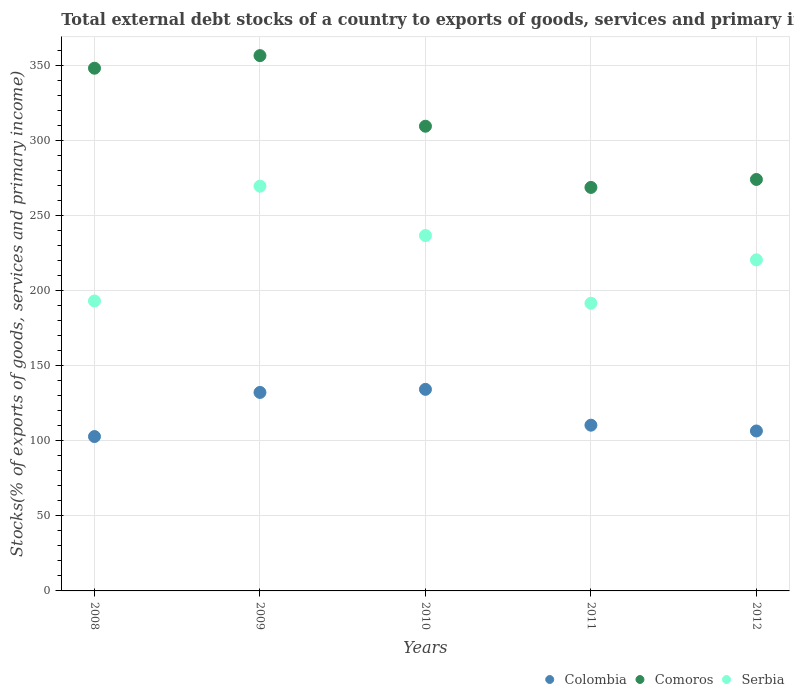What is the total debt stocks in Comoros in 2011?
Your response must be concise. 268.71. Across all years, what is the maximum total debt stocks in Comoros?
Give a very brief answer. 356.48. Across all years, what is the minimum total debt stocks in Colombia?
Your answer should be compact. 102.8. What is the total total debt stocks in Colombia in the graph?
Make the answer very short. 586.12. What is the difference between the total debt stocks in Colombia in 2011 and that in 2012?
Offer a very short reply. 3.86. What is the difference between the total debt stocks in Comoros in 2010 and the total debt stocks in Serbia in 2012?
Your response must be concise. 88.97. What is the average total debt stocks in Serbia per year?
Your answer should be very brief. 222.27. In the year 2009, what is the difference between the total debt stocks in Colombia and total debt stocks in Serbia?
Offer a very short reply. -137.37. What is the ratio of the total debt stocks in Colombia in 2008 to that in 2011?
Ensure brevity in your answer.  0.93. Is the difference between the total debt stocks in Colombia in 2011 and 2012 greater than the difference between the total debt stocks in Serbia in 2011 and 2012?
Ensure brevity in your answer.  Yes. What is the difference between the highest and the second highest total debt stocks in Serbia?
Keep it short and to the point. 32.89. What is the difference between the highest and the lowest total debt stocks in Comoros?
Your answer should be very brief. 87.77. In how many years, is the total debt stocks in Comoros greater than the average total debt stocks in Comoros taken over all years?
Offer a terse response. 2. Is the total debt stocks in Serbia strictly greater than the total debt stocks in Comoros over the years?
Offer a terse response. No. How many dotlines are there?
Provide a short and direct response. 3. How many years are there in the graph?
Your answer should be very brief. 5. Are the values on the major ticks of Y-axis written in scientific E-notation?
Provide a succinct answer. No. Does the graph contain any zero values?
Provide a succinct answer. No. Where does the legend appear in the graph?
Offer a terse response. Bottom right. How many legend labels are there?
Give a very brief answer. 3. What is the title of the graph?
Provide a short and direct response. Total external debt stocks of a country to exports of goods, services and primary income. Does "Middle East & North Africa (all income levels)" appear as one of the legend labels in the graph?
Offer a terse response. No. What is the label or title of the X-axis?
Make the answer very short. Years. What is the label or title of the Y-axis?
Give a very brief answer. Stocks(% of exports of goods, services and primary income). What is the Stocks(% of exports of goods, services and primary income) of Colombia in 2008?
Your response must be concise. 102.8. What is the Stocks(% of exports of goods, services and primary income) of Comoros in 2008?
Keep it short and to the point. 348.1. What is the Stocks(% of exports of goods, services and primary income) in Serbia in 2008?
Provide a short and direct response. 193.09. What is the Stocks(% of exports of goods, services and primary income) in Colombia in 2009?
Provide a succinct answer. 132.18. What is the Stocks(% of exports of goods, services and primary income) of Comoros in 2009?
Keep it short and to the point. 356.48. What is the Stocks(% of exports of goods, services and primary income) of Serbia in 2009?
Offer a very short reply. 269.55. What is the Stocks(% of exports of goods, services and primary income) in Colombia in 2010?
Your answer should be compact. 134.24. What is the Stocks(% of exports of goods, services and primary income) of Comoros in 2010?
Offer a very short reply. 309.46. What is the Stocks(% of exports of goods, services and primary income) in Serbia in 2010?
Keep it short and to the point. 236.67. What is the Stocks(% of exports of goods, services and primary income) of Colombia in 2011?
Provide a succinct answer. 110.38. What is the Stocks(% of exports of goods, services and primary income) of Comoros in 2011?
Offer a terse response. 268.71. What is the Stocks(% of exports of goods, services and primary income) in Serbia in 2011?
Make the answer very short. 191.56. What is the Stocks(% of exports of goods, services and primary income) of Colombia in 2012?
Make the answer very short. 106.52. What is the Stocks(% of exports of goods, services and primary income) of Comoros in 2012?
Provide a short and direct response. 274.02. What is the Stocks(% of exports of goods, services and primary income) in Serbia in 2012?
Provide a succinct answer. 220.5. Across all years, what is the maximum Stocks(% of exports of goods, services and primary income) of Colombia?
Provide a succinct answer. 134.24. Across all years, what is the maximum Stocks(% of exports of goods, services and primary income) of Comoros?
Provide a succinct answer. 356.48. Across all years, what is the maximum Stocks(% of exports of goods, services and primary income) of Serbia?
Ensure brevity in your answer.  269.55. Across all years, what is the minimum Stocks(% of exports of goods, services and primary income) in Colombia?
Keep it short and to the point. 102.8. Across all years, what is the minimum Stocks(% of exports of goods, services and primary income) in Comoros?
Provide a short and direct response. 268.71. Across all years, what is the minimum Stocks(% of exports of goods, services and primary income) of Serbia?
Your response must be concise. 191.56. What is the total Stocks(% of exports of goods, services and primary income) in Colombia in the graph?
Provide a succinct answer. 586.12. What is the total Stocks(% of exports of goods, services and primary income) of Comoros in the graph?
Provide a succinct answer. 1556.78. What is the total Stocks(% of exports of goods, services and primary income) in Serbia in the graph?
Your response must be concise. 1111.37. What is the difference between the Stocks(% of exports of goods, services and primary income) of Colombia in 2008 and that in 2009?
Provide a short and direct response. -29.38. What is the difference between the Stocks(% of exports of goods, services and primary income) of Comoros in 2008 and that in 2009?
Your answer should be compact. -8.38. What is the difference between the Stocks(% of exports of goods, services and primary income) of Serbia in 2008 and that in 2009?
Ensure brevity in your answer.  -76.47. What is the difference between the Stocks(% of exports of goods, services and primary income) in Colombia in 2008 and that in 2010?
Your response must be concise. -31.43. What is the difference between the Stocks(% of exports of goods, services and primary income) of Comoros in 2008 and that in 2010?
Offer a terse response. 38.64. What is the difference between the Stocks(% of exports of goods, services and primary income) of Serbia in 2008 and that in 2010?
Provide a succinct answer. -43.58. What is the difference between the Stocks(% of exports of goods, services and primary income) in Colombia in 2008 and that in 2011?
Your answer should be compact. -7.58. What is the difference between the Stocks(% of exports of goods, services and primary income) of Comoros in 2008 and that in 2011?
Provide a succinct answer. 79.39. What is the difference between the Stocks(% of exports of goods, services and primary income) in Serbia in 2008 and that in 2011?
Give a very brief answer. 1.53. What is the difference between the Stocks(% of exports of goods, services and primary income) of Colombia in 2008 and that in 2012?
Your answer should be very brief. -3.71. What is the difference between the Stocks(% of exports of goods, services and primary income) in Comoros in 2008 and that in 2012?
Offer a terse response. 74.08. What is the difference between the Stocks(% of exports of goods, services and primary income) of Serbia in 2008 and that in 2012?
Your response must be concise. -27.41. What is the difference between the Stocks(% of exports of goods, services and primary income) in Colombia in 2009 and that in 2010?
Your answer should be very brief. -2.05. What is the difference between the Stocks(% of exports of goods, services and primary income) of Comoros in 2009 and that in 2010?
Ensure brevity in your answer.  47.02. What is the difference between the Stocks(% of exports of goods, services and primary income) in Serbia in 2009 and that in 2010?
Ensure brevity in your answer.  32.89. What is the difference between the Stocks(% of exports of goods, services and primary income) of Colombia in 2009 and that in 2011?
Offer a terse response. 21.81. What is the difference between the Stocks(% of exports of goods, services and primary income) in Comoros in 2009 and that in 2011?
Your answer should be compact. 87.77. What is the difference between the Stocks(% of exports of goods, services and primary income) of Serbia in 2009 and that in 2011?
Offer a very short reply. 77.99. What is the difference between the Stocks(% of exports of goods, services and primary income) of Colombia in 2009 and that in 2012?
Provide a succinct answer. 25.67. What is the difference between the Stocks(% of exports of goods, services and primary income) of Comoros in 2009 and that in 2012?
Offer a terse response. 82.47. What is the difference between the Stocks(% of exports of goods, services and primary income) of Serbia in 2009 and that in 2012?
Provide a short and direct response. 49.06. What is the difference between the Stocks(% of exports of goods, services and primary income) in Colombia in 2010 and that in 2011?
Provide a succinct answer. 23.86. What is the difference between the Stocks(% of exports of goods, services and primary income) in Comoros in 2010 and that in 2011?
Ensure brevity in your answer.  40.75. What is the difference between the Stocks(% of exports of goods, services and primary income) of Serbia in 2010 and that in 2011?
Your answer should be very brief. 45.11. What is the difference between the Stocks(% of exports of goods, services and primary income) of Colombia in 2010 and that in 2012?
Your answer should be very brief. 27.72. What is the difference between the Stocks(% of exports of goods, services and primary income) of Comoros in 2010 and that in 2012?
Give a very brief answer. 35.44. What is the difference between the Stocks(% of exports of goods, services and primary income) of Serbia in 2010 and that in 2012?
Keep it short and to the point. 16.17. What is the difference between the Stocks(% of exports of goods, services and primary income) of Colombia in 2011 and that in 2012?
Your answer should be compact. 3.86. What is the difference between the Stocks(% of exports of goods, services and primary income) in Comoros in 2011 and that in 2012?
Ensure brevity in your answer.  -5.31. What is the difference between the Stocks(% of exports of goods, services and primary income) in Serbia in 2011 and that in 2012?
Keep it short and to the point. -28.94. What is the difference between the Stocks(% of exports of goods, services and primary income) in Colombia in 2008 and the Stocks(% of exports of goods, services and primary income) in Comoros in 2009?
Keep it short and to the point. -253.68. What is the difference between the Stocks(% of exports of goods, services and primary income) of Colombia in 2008 and the Stocks(% of exports of goods, services and primary income) of Serbia in 2009?
Keep it short and to the point. -166.75. What is the difference between the Stocks(% of exports of goods, services and primary income) in Comoros in 2008 and the Stocks(% of exports of goods, services and primary income) in Serbia in 2009?
Your response must be concise. 78.55. What is the difference between the Stocks(% of exports of goods, services and primary income) in Colombia in 2008 and the Stocks(% of exports of goods, services and primary income) in Comoros in 2010?
Keep it short and to the point. -206.66. What is the difference between the Stocks(% of exports of goods, services and primary income) in Colombia in 2008 and the Stocks(% of exports of goods, services and primary income) in Serbia in 2010?
Provide a short and direct response. -133.87. What is the difference between the Stocks(% of exports of goods, services and primary income) in Comoros in 2008 and the Stocks(% of exports of goods, services and primary income) in Serbia in 2010?
Keep it short and to the point. 111.43. What is the difference between the Stocks(% of exports of goods, services and primary income) of Colombia in 2008 and the Stocks(% of exports of goods, services and primary income) of Comoros in 2011?
Your answer should be compact. -165.91. What is the difference between the Stocks(% of exports of goods, services and primary income) in Colombia in 2008 and the Stocks(% of exports of goods, services and primary income) in Serbia in 2011?
Provide a short and direct response. -88.76. What is the difference between the Stocks(% of exports of goods, services and primary income) of Comoros in 2008 and the Stocks(% of exports of goods, services and primary income) of Serbia in 2011?
Give a very brief answer. 156.54. What is the difference between the Stocks(% of exports of goods, services and primary income) of Colombia in 2008 and the Stocks(% of exports of goods, services and primary income) of Comoros in 2012?
Keep it short and to the point. -171.21. What is the difference between the Stocks(% of exports of goods, services and primary income) in Colombia in 2008 and the Stocks(% of exports of goods, services and primary income) in Serbia in 2012?
Your response must be concise. -117.69. What is the difference between the Stocks(% of exports of goods, services and primary income) of Comoros in 2008 and the Stocks(% of exports of goods, services and primary income) of Serbia in 2012?
Keep it short and to the point. 127.6. What is the difference between the Stocks(% of exports of goods, services and primary income) of Colombia in 2009 and the Stocks(% of exports of goods, services and primary income) of Comoros in 2010?
Your answer should be very brief. -177.28. What is the difference between the Stocks(% of exports of goods, services and primary income) of Colombia in 2009 and the Stocks(% of exports of goods, services and primary income) of Serbia in 2010?
Offer a very short reply. -104.48. What is the difference between the Stocks(% of exports of goods, services and primary income) in Comoros in 2009 and the Stocks(% of exports of goods, services and primary income) in Serbia in 2010?
Your response must be concise. 119.82. What is the difference between the Stocks(% of exports of goods, services and primary income) in Colombia in 2009 and the Stocks(% of exports of goods, services and primary income) in Comoros in 2011?
Your response must be concise. -136.53. What is the difference between the Stocks(% of exports of goods, services and primary income) of Colombia in 2009 and the Stocks(% of exports of goods, services and primary income) of Serbia in 2011?
Your response must be concise. -59.38. What is the difference between the Stocks(% of exports of goods, services and primary income) of Comoros in 2009 and the Stocks(% of exports of goods, services and primary income) of Serbia in 2011?
Make the answer very short. 164.92. What is the difference between the Stocks(% of exports of goods, services and primary income) of Colombia in 2009 and the Stocks(% of exports of goods, services and primary income) of Comoros in 2012?
Offer a terse response. -141.83. What is the difference between the Stocks(% of exports of goods, services and primary income) in Colombia in 2009 and the Stocks(% of exports of goods, services and primary income) in Serbia in 2012?
Make the answer very short. -88.31. What is the difference between the Stocks(% of exports of goods, services and primary income) of Comoros in 2009 and the Stocks(% of exports of goods, services and primary income) of Serbia in 2012?
Ensure brevity in your answer.  135.99. What is the difference between the Stocks(% of exports of goods, services and primary income) in Colombia in 2010 and the Stocks(% of exports of goods, services and primary income) in Comoros in 2011?
Your response must be concise. -134.47. What is the difference between the Stocks(% of exports of goods, services and primary income) of Colombia in 2010 and the Stocks(% of exports of goods, services and primary income) of Serbia in 2011?
Ensure brevity in your answer.  -57.32. What is the difference between the Stocks(% of exports of goods, services and primary income) in Comoros in 2010 and the Stocks(% of exports of goods, services and primary income) in Serbia in 2011?
Your response must be concise. 117.9. What is the difference between the Stocks(% of exports of goods, services and primary income) in Colombia in 2010 and the Stocks(% of exports of goods, services and primary income) in Comoros in 2012?
Keep it short and to the point. -139.78. What is the difference between the Stocks(% of exports of goods, services and primary income) in Colombia in 2010 and the Stocks(% of exports of goods, services and primary income) in Serbia in 2012?
Offer a very short reply. -86.26. What is the difference between the Stocks(% of exports of goods, services and primary income) of Comoros in 2010 and the Stocks(% of exports of goods, services and primary income) of Serbia in 2012?
Offer a terse response. 88.97. What is the difference between the Stocks(% of exports of goods, services and primary income) in Colombia in 2011 and the Stocks(% of exports of goods, services and primary income) in Comoros in 2012?
Give a very brief answer. -163.64. What is the difference between the Stocks(% of exports of goods, services and primary income) in Colombia in 2011 and the Stocks(% of exports of goods, services and primary income) in Serbia in 2012?
Provide a succinct answer. -110.12. What is the difference between the Stocks(% of exports of goods, services and primary income) of Comoros in 2011 and the Stocks(% of exports of goods, services and primary income) of Serbia in 2012?
Your response must be concise. 48.22. What is the average Stocks(% of exports of goods, services and primary income) in Colombia per year?
Ensure brevity in your answer.  117.22. What is the average Stocks(% of exports of goods, services and primary income) in Comoros per year?
Provide a succinct answer. 311.36. What is the average Stocks(% of exports of goods, services and primary income) in Serbia per year?
Your answer should be very brief. 222.27. In the year 2008, what is the difference between the Stocks(% of exports of goods, services and primary income) in Colombia and Stocks(% of exports of goods, services and primary income) in Comoros?
Give a very brief answer. -245.3. In the year 2008, what is the difference between the Stocks(% of exports of goods, services and primary income) in Colombia and Stocks(% of exports of goods, services and primary income) in Serbia?
Give a very brief answer. -90.29. In the year 2008, what is the difference between the Stocks(% of exports of goods, services and primary income) in Comoros and Stocks(% of exports of goods, services and primary income) in Serbia?
Keep it short and to the point. 155.01. In the year 2009, what is the difference between the Stocks(% of exports of goods, services and primary income) in Colombia and Stocks(% of exports of goods, services and primary income) in Comoros?
Your answer should be very brief. -224.3. In the year 2009, what is the difference between the Stocks(% of exports of goods, services and primary income) of Colombia and Stocks(% of exports of goods, services and primary income) of Serbia?
Your answer should be very brief. -137.37. In the year 2009, what is the difference between the Stocks(% of exports of goods, services and primary income) of Comoros and Stocks(% of exports of goods, services and primary income) of Serbia?
Ensure brevity in your answer.  86.93. In the year 2010, what is the difference between the Stocks(% of exports of goods, services and primary income) in Colombia and Stocks(% of exports of goods, services and primary income) in Comoros?
Keep it short and to the point. -175.22. In the year 2010, what is the difference between the Stocks(% of exports of goods, services and primary income) of Colombia and Stocks(% of exports of goods, services and primary income) of Serbia?
Keep it short and to the point. -102.43. In the year 2010, what is the difference between the Stocks(% of exports of goods, services and primary income) of Comoros and Stocks(% of exports of goods, services and primary income) of Serbia?
Your answer should be compact. 72.79. In the year 2011, what is the difference between the Stocks(% of exports of goods, services and primary income) in Colombia and Stocks(% of exports of goods, services and primary income) in Comoros?
Make the answer very short. -158.33. In the year 2011, what is the difference between the Stocks(% of exports of goods, services and primary income) of Colombia and Stocks(% of exports of goods, services and primary income) of Serbia?
Ensure brevity in your answer.  -81.18. In the year 2011, what is the difference between the Stocks(% of exports of goods, services and primary income) in Comoros and Stocks(% of exports of goods, services and primary income) in Serbia?
Keep it short and to the point. 77.15. In the year 2012, what is the difference between the Stocks(% of exports of goods, services and primary income) of Colombia and Stocks(% of exports of goods, services and primary income) of Comoros?
Your answer should be compact. -167.5. In the year 2012, what is the difference between the Stocks(% of exports of goods, services and primary income) of Colombia and Stocks(% of exports of goods, services and primary income) of Serbia?
Provide a succinct answer. -113.98. In the year 2012, what is the difference between the Stocks(% of exports of goods, services and primary income) in Comoros and Stocks(% of exports of goods, services and primary income) in Serbia?
Provide a succinct answer. 53.52. What is the ratio of the Stocks(% of exports of goods, services and primary income) of Colombia in 2008 to that in 2009?
Give a very brief answer. 0.78. What is the ratio of the Stocks(% of exports of goods, services and primary income) of Comoros in 2008 to that in 2009?
Your answer should be compact. 0.98. What is the ratio of the Stocks(% of exports of goods, services and primary income) of Serbia in 2008 to that in 2009?
Make the answer very short. 0.72. What is the ratio of the Stocks(% of exports of goods, services and primary income) of Colombia in 2008 to that in 2010?
Your response must be concise. 0.77. What is the ratio of the Stocks(% of exports of goods, services and primary income) in Comoros in 2008 to that in 2010?
Provide a succinct answer. 1.12. What is the ratio of the Stocks(% of exports of goods, services and primary income) in Serbia in 2008 to that in 2010?
Your answer should be compact. 0.82. What is the ratio of the Stocks(% of exports of goods, services and primary income) of Colombia in 2008 to that in 2011?
Offer a terse response. 0.93. What is the ratio of the Stocks(% of exports of goods, services and primary income) in Comoros in 2008 to that in 2011?
Your answer should be compact. 1.3. What is the ratio of the Stocks(% of exports of goods, services and primary income) in Serbia in 2008 to that in 2011?
Your response must be concise. 1.01. What is the ratio of the Stocks(% of exports of goods, services and primary income) in Colombia in 2008 to that in 2012?
Give a very brief answer. 0.97. What is the ratio of the Stocks(% of exports of goods, services and primary income) of Comoros in 2008 to that in 2012?
Make the answer very short. 1.27. What is the ratio of the Stocks(% of exports of goods, services and primary income) of Serbia in 2008 to that in 2012?
Offer a terse response. 0.88. What is the ratio of the Stocks(% of exports of goods, services and primary income) in Colombia in 2009 to that in 2010?
Provide a succinct answer. 0.98. What is the ratio of the Stocks(% of exports of goods, services and primary income) of Comoros in 2009 to that in 2010?
Ensure brevity in your answer.  1.15. What is the ratio of the Stocks(% of exports of goods, services and primary income) of Serbia in 2009 to that in 2010?
Give a very brief answer. 1.14. What is the ratio of the Stocks(% of exports of goods, services and primary income) in Colombia in 2009 to that in 2011?
Your response must be concise. 1.2. What is the ratio of the Stocks(% of exports of goods, services and primary income) of Comoros in 2009 to that in 2011?
Provide a short and direct response. 1.33. What is the ratio of the Stocks(% of exports of goods, services and primary income) in Serbia in 2009 to that in 2011?
Keep it short and to the point. 1.41. What is the ratio of the Stocks(% of exports of goods, services and primary income) of Colombia in 2009 to that in 2012?
Make the answer very short. 1.24. What is the ratio of the Stocks(% of exports of goods, services and primary income) in Comoros in 2009 to that in 2012?
Your response must be concise. 1.3. What is the ratio of the Stocks(% of exports of goods, services and primary income) in Serbia in 2009 to that in 2012?
Give a very brief answer. 1.22. What is the ratio of the Stocks(% of exports of goods, services and primary income) of Colombia in 2010 to that in 2011?
Ensure brevity in your answer.  1.22. What is the ratio of the Stocks(% of exports of goods, services and primary income) of Comoros in 2010 to that in 2011?
Make the answer very short. 1.15. What is the ratio of the Stocks(% of exports of goods, services and primary income) of Serbia in 2010 to that in 2011?
Ensure brevity in your answer.  1.24. What is the ratio of the Stocks(% of exports of goods, services and primary income) of Colombia in 2010 to that in 2012?
Make the answer very short. 1.26. What is the ratio of the Stocks(% of exports of goods, services and primary income) of Comoros in 2010 to that in 2012?
Your answer should be compact. 1.13. What is the ratio of the Stocks(% of exports of goods, services and primary income) of Serbia in 2010 to that in 2012?
Ensure brevity in your answer.  1.07. What is the ratio of the Stocks(% of exports of goods, services and primary income) of Colombia in 2011 to that in 2012?
Provide a short and direct response. 1.04. What is the ratio of the Stocks(% of exports of goods, services and primary income) of Comoros in 2011 to that in 2012?
Your response must be concise. 0.98. What is the ratio of the Stocks(% of exports of goods, services and primary income) of Serbia in 2011 to that in 2012?
Give a very brief answer. 0.87. What is the difference between the highest and the second highest Stocks(% of exports of goods, services and primary income) in Colombia?
Provide a short and direct response. 2.05. What is the difference between the highest and the second highest Stocks(% of exports of goods, services and primary income) of Comoros?
Your response must be concise. 8.38. What is the difference between the highest and the second highest Stocks(% of exports of goods, services and primary income) in Serbia?
Ensure brevity in your answer.  32.89. What is the difference between the highest and the lowest Stocks(% of exports of goods, services and primary income) in Colombia?
Give a very brief answer. 31.43. What is the difference between the highest and the lowest Stocks(% of exports of goods, services and primary income) of Comoros?
Provide a succinct answer. 87.77. What is the difference between the highest and the lowest Stocks(% of exports of goods, services and primary income) of Serbia?
Provide a short and direct response. 77.99. 